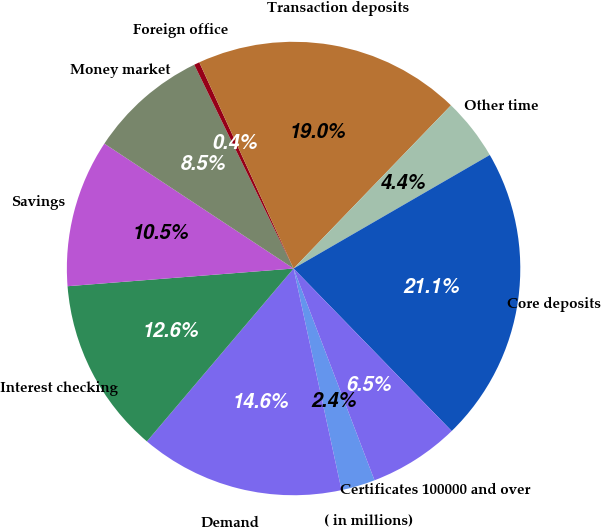Convert chart to OTSL. <chart><loc_0><loc_0><loc_500><loc_500><pie_chart><fcel>( in millions)<fcel>Demand<fcel>Interest checking<fcel>Savings<fcel>Money market<fcel>Foreign office<fcel>Transaction deposits<fcel>Other time<fcel>Core deposits<fcel>Certificates 100000 and over<nl><fcel>2.42%<fcel>14.59%<fcel>12.56%<fcel>10.53%<fcel>8.5%<fcel>0.39%<fcel>19.04%<fcel>4.44%<fcel>21.07%<fcel>6.47%<nl></chart> 